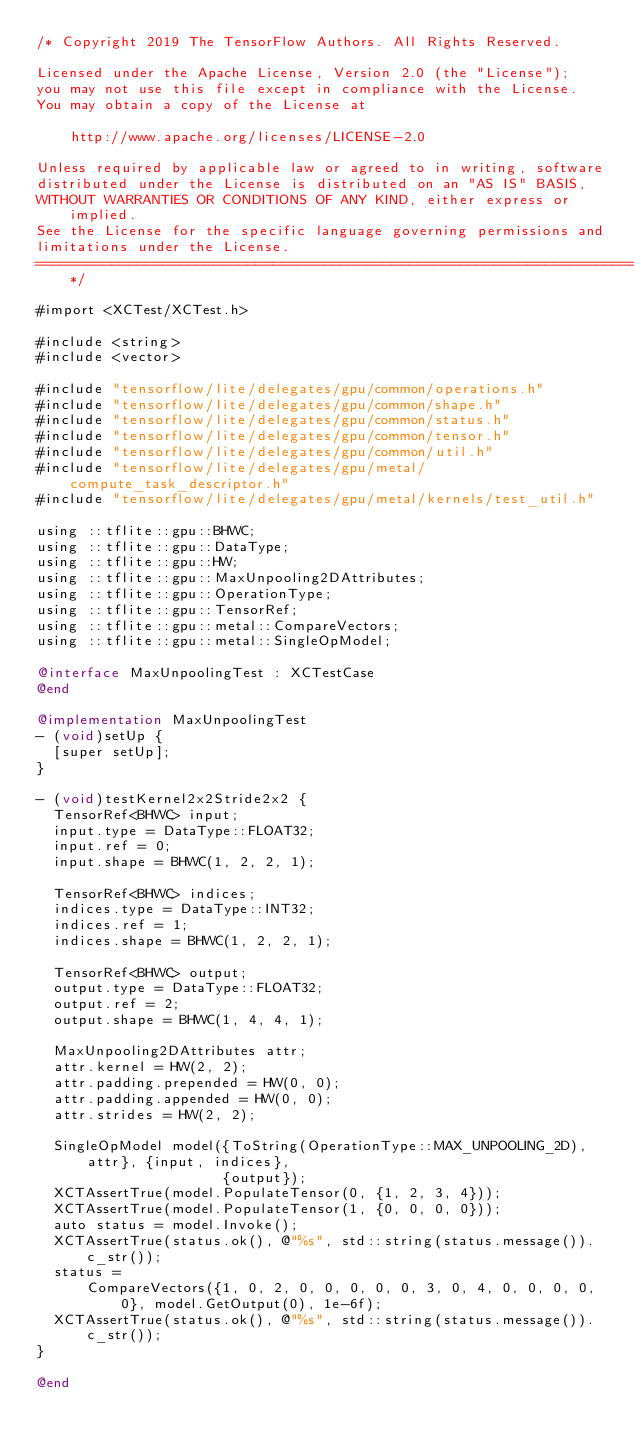<code> <loc_0><loc_0><loc_500><loc_500><_ObjectiveC_>/* Copyright 2019 The TensorFlow Authors. All Rights Reserved.

Licensed under the Apache License, Version 2.0 (the "License");
you may not use this file except in compliance with the License.
You may obtain a copy of the License at

    http://www.apache.org/licenses/LICENSE-2.0

Unless required by applicable law or agreed to in writing, software
distributed under the License is distributed on an "AS IS" BASIS,
WITHOUT WARRANTIES OR CONDITIONS OF ANY KIND, either express or implied.
See the License for the specific language governing permissions and
limitations under the License.
==============================================================================*/

#import <XCTest/XCTest.h>

#include <string>
#include <vector>

#include "tensorflow/lite/delegates/gpu/common/operations.h"
#include "tensorflow/lite/delegates/gpu/common/shape.h"
#include "tensorflow/lite/delegates/gpu/common/status.h"
#include "tensorflow/lite/delegates/gpu/common/tensor.h"
#include "tensorflow/lite/delegates/gpu/common/util.h"
#include "tensorflow/lite/delegates/gpu/metal/compute_task_descriptor.h"
#include "tensorflow/lite/delegates/gpu/metal/kernels/test_util.h"

using ::tflite::gpu::BHWC;
using ::tflite::gpu::DataType;
using ::tflite::gpu::HW;
using ::tflite::gpu::MaxUnpooling2DAttributes;
using ::tflite::gpu::OperationType;
using ::tflite::gpu::TensorRef;
using ::tflite::gpu::metal::CompareVectors;
using ::tflite::gpu::metal::SingleOpModel;

@interface MaxUnpoolingTest : XCTestCase
@end

@implementation MaxUnpoolingTest
- (void)setUp {
  [super setUp];
}

- (void)testKernel2x2Stride2x2 {
  TensorRef<BHWC> input;
  input.type = DataType::FLOAT32;
  input.ref = 0;
  input.shape = BHWC(1, 2, 2, 1);

  TensorRef<BHWC> indices;
  indices.type = DataType::INT32;
  indices.ref = 1;
  indices.shape = BHWC(1, 2, 2, 1);

  TensorRef<BHWC> output;
  output.type = DataType::FLOAT32;
  output.ref = 2;
  output.shape = BHWC(1, 4, 4, 1);

  MaxUnpooling2DAttributes attr;
  attr.kernel = HW(2, 2);
  attr.padding.prepended = HW(0, 0);
  attr.padding.appended = HW(0, 0);
  attr.strides = HW(2, 2);

  SingleOpModel model({ToString(OperationType::MAX_UNPOOLING_2D), attr}, {input, indices},
                      {output});
  XCTAssertTrue(model.PopulateTensor(0, {1, 2, 3, 4}));
  XCTAssertTrue(model.PopulateTensor(1, {0, 0, 0, 0}));
  auto status = model.Invoke();
  XCTAssertTrue(status.ok(), @"%s", std::string(status.message()).c_str());
  status =
      CompareVectors({1, 0, 2, 0, 0, 0, 0, 0, 3, 0, 4, 0, 0, 0, 0, 0}, model.GetOutput(0), 1e-6f);
  XCTAssertTrue(status.ok(), @"%s", std::string(status.message()).c_str());
}

@end
</code> 